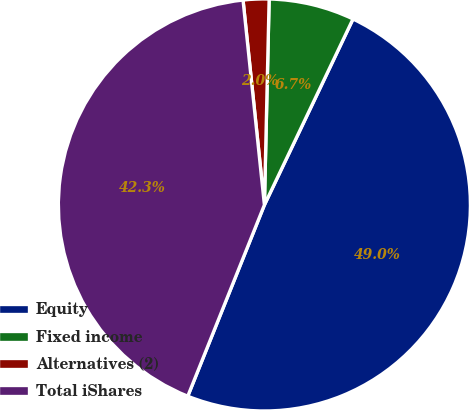<chart> <loc_0><loc_0><loc_500><loc_500><pie_chart><fcel>Equity<fcel>Fixed income<fcel>Alternatives (2)<fcel>Total iShares<nl><fcel>48.99%<fcel>6.71%<fcel>2.02%<fcel>42.28%<nl></chart> 